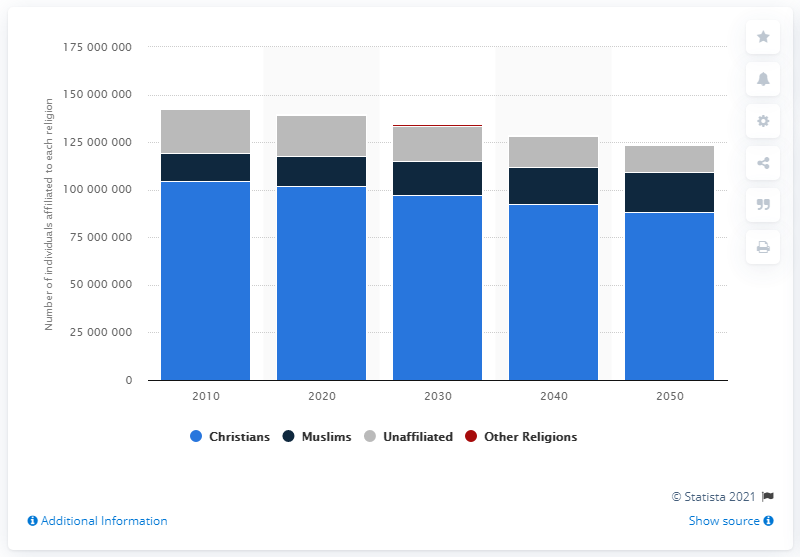Indicate a few pertinent items in this graphic. Russia has the second largest Muslim population among its believers. 